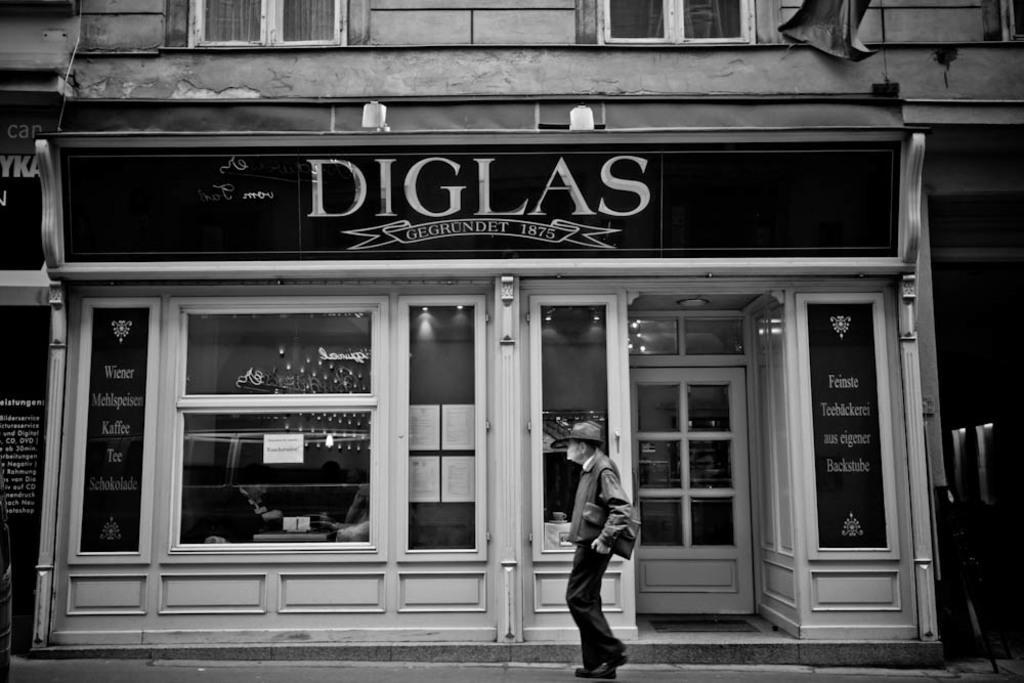In one or two sentences, can you explain what this image depicts? In this image we can see a person holding a file, he is walking, there is a house, windows, a door, there are boards with text on them, also we can see the lights, and the picture is taken in black and white mode. 